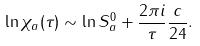<formula> <loc_0><loc_0><loc_500><loc_500>\ln \chi _ { a } ( \tau ) & \sim \ln S _ { a } ^ { 0 } + \frac { 2 \pi { i } } { \tau } \frac { c } { 2 4 } .</formula> 